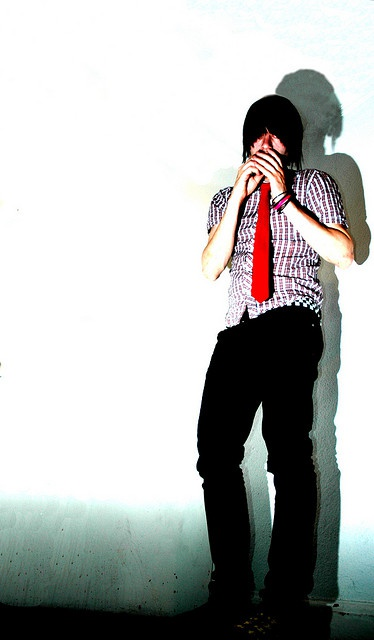Describe the objects in this image and their specific colors. I can see people in white, black, gray, and red tones and tie in white, red, brown, black, and maroon tones in this image. 